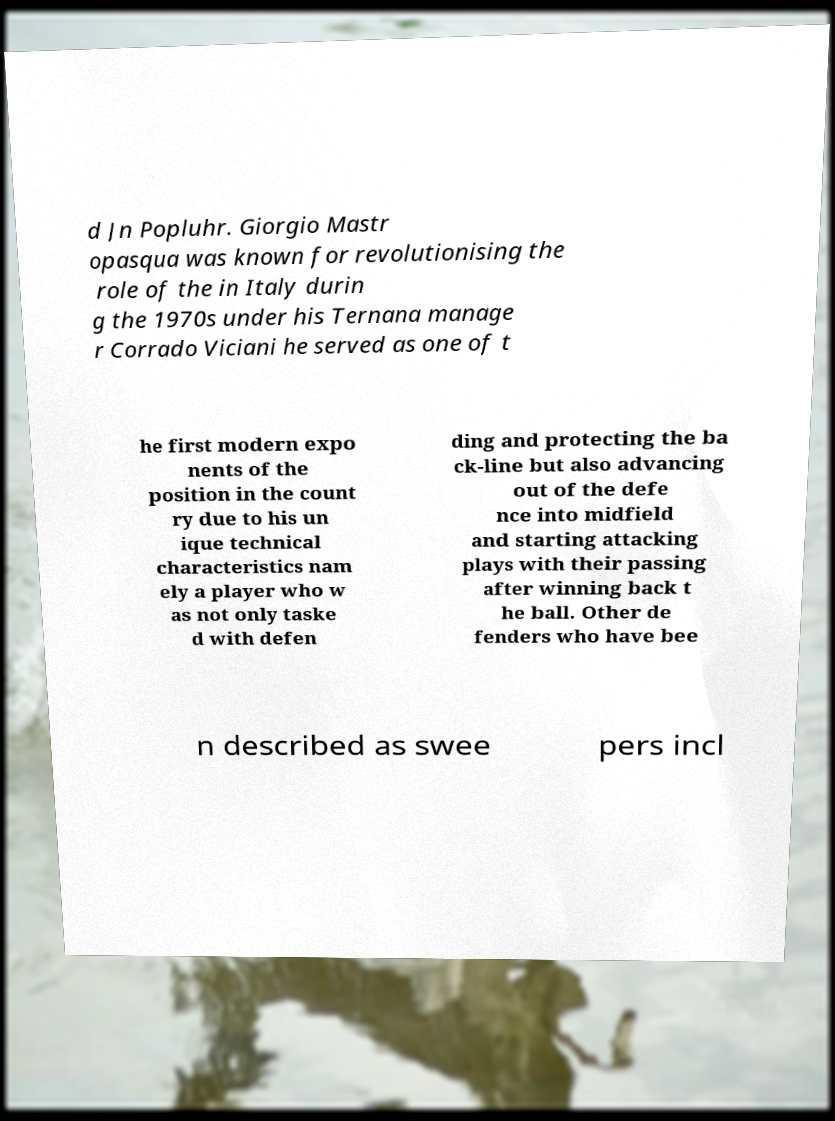Please identify and transcribe the text found in this image. d Jn Popluhr. Giorgio Mastr opasqua was known for revolutionising the role of the in Italy durin g the 1970s under his Ternana manage r Corrado Viciani he served as one of t he first modern expo nents of the position in the count ry due to his un ique technical characteristics nam ely a player who w as not only taske d with defen ding and protecting the ba ck-line but also advancing out of the defe nce into midfield and starting attacking plays with their passing after winning back t he ball. Other de fenders who have bee n described as swee pers incl 